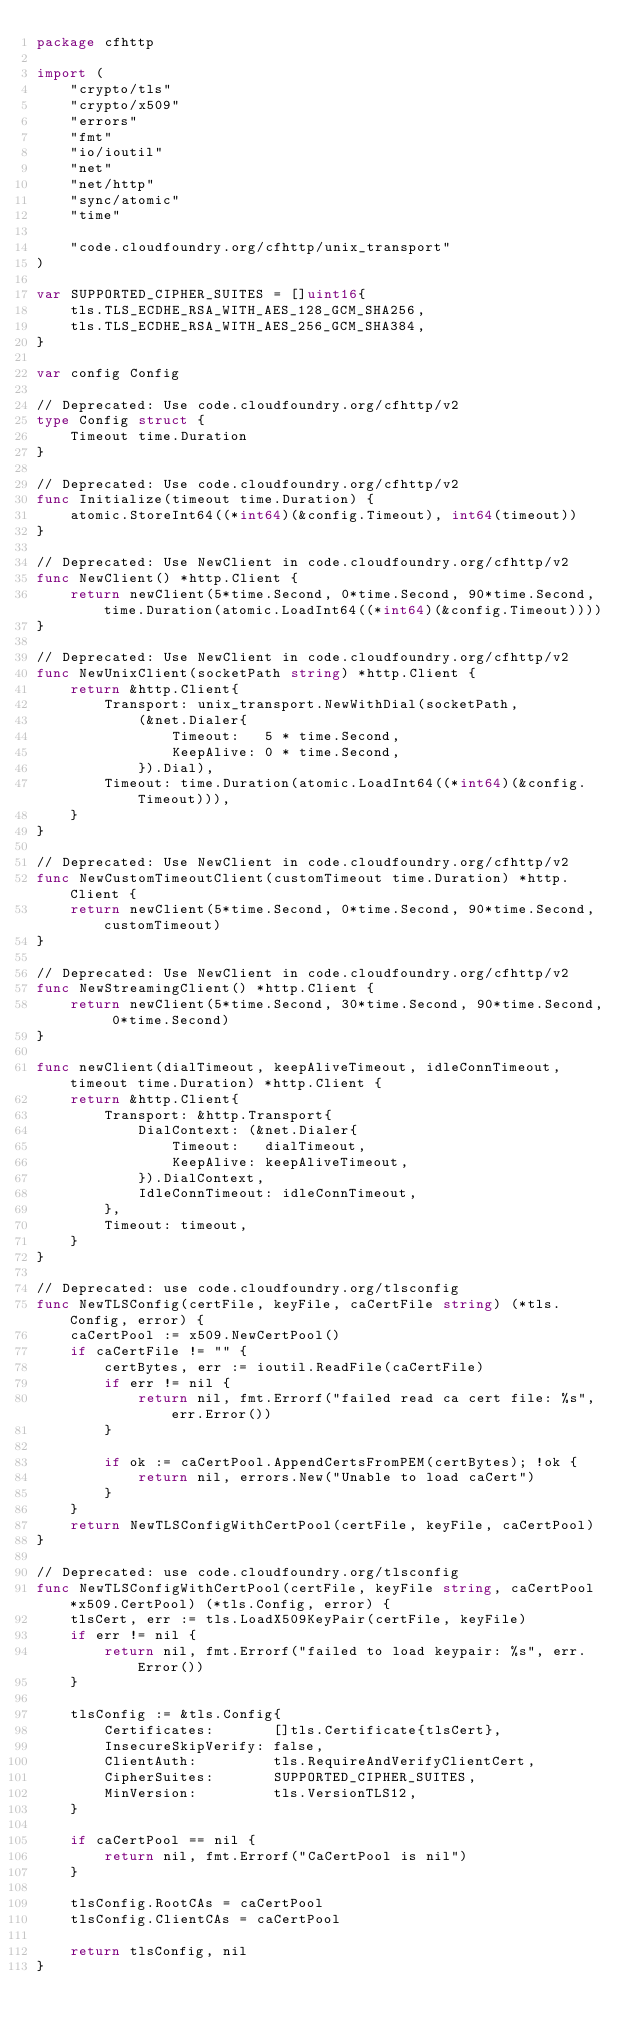Convert code to text. <code><loc_0><loc_0><loc_500><loc_500><_Go_>package cfhttp

import (
	"crypto/tls"
	"crypto/x509"
	"errors"
	"fmt"
	"io/ioutil"
	"net"
	"net/http"
	"sync/atomic"
	"time"

	"code.cloudfoundry.org/cfhttp/unix_transport"
)

var SUPPORTED_CIPHER_SUITES = []uint16{
	tls.TLS_ECDHE_RSA_WITH_AES_128_GCM_SHA256,
	tls.TLS_ECDHE_RSA_WITH_AES_256_GCM_SHA384,
}

var config Config

// Deprecated: Use code.cloudfoundry.org/cfhttp/v2
type Config struct {
	Timeout time.Duration
}

// Deprecated: Use code.cloudfoundry.org/cfhttp/v2
func Initialize(timeout time.Duration) {
	atomic.StoreInt64((*int64)(&config.Timeout), int64(timeout))
}

// Deprecated: Use NewClient in code.cloudfoundry.org/cfhttp/v2
func NewClient() *http.Client {
	return newClient(5*time.Second, 0*time.Second, 90*time.Second, time.Duration(atomic.LoadInt64((*int64)(&config.Timeout))))
}

// Deprecated: Use NewClient in code.cloudfoundry.org/cfhttp/v2
func NewUnixClient(socketPath string) *http.Client {
	return &http.Client{
		Transport: unix_transport.NewWithDial(socketPath,
			(&net.Dialer{
				Timeout:   5 * time.Second,
				KeepAlive: 0 * time.Second,
			}).Dial),
		Timeout: time.Duration(atomic.LoadInt64((*int64)(&config.Timeout))),
	}
}

// Deprecated: Use NewClient in code.cloudfoundry.org/cfhttp/v2
func NewCustomTimeoutClient(customTimeout time.Duration) *http.Client {
	return newClient(5*time.Second, 0*time.Second, 90*time.Second, customTimeout)
}

// Deprecated: Use NewClient in code.cloudfoundry.org/cfhttp/v2
func NewStreamingClient() *http.Client {
	return newClient(5*time.Second, 30*time.Second, 90*time.Second, 0*time.Second)
}

func newClient(dialTimeout, keepAliveTimeout, idleConnTimeout, timeout time.Duration) *http.Client {
	return &http.Client{
		Transport: &http.Transport{
			DialContext: (&net.Dialer{
				Timeout:   dialTimeout,
				KeepAlive: keepAliveTimeout,
			}).DialContext,
			IdleConnTimeout: idleConnTimeout,
		},
		Timeout: timeout,
	}
}

// Deprecated: use code.cloudfoundry.org/tlsconfig
func NewTLSConfig(certFile, keyFile, caCertFile string) (*tls.Config, error) {
	caCertPool := x509.NewCertPool()
	if caCertFile != "" {
		certBytes, err := ioutil.ReadFile(caCertFile)
		if err != nil {
			return nil, fmt.Errorf("failed read ca cert file: %s", err.Error())
		}

		if ok := caCertPool.AppendCertsFromPEM(certBytes); !ok {
			return nil, errors.New("Unable to load caCert")
		}
	}
	return NewTLSConfigWithCertPool(certFile, keyFile, caCertPool)
}

// Deprecated: use code.cloudfoundry.org/tlsconfig
func NewTLSConfigWithCertPool(certFile, keyFile string, caCertPool *x509.CertPool) (*tls.Config, error) {
	tlsCert, err := tls.LoadX509KeyPair(certFile, keyFile)
	if err != nil {
		return nil, fmt.Errorf("failed to load keypair: %s", err.Error())
	}

	tlsConfig := &tls.Config{
		Certificates:       []tls.Certificate{tlsCert},
		InsecureSkipVerify: false,
		ClientAuth:         tls.RequireAndVerifyClientCert,
		CipherSuites:       SUPPORTED_CIPHER_SUITES,
		MinVersion:         tls.VersionTLS12,
	}

	if caCertPool == nil {
		return nil, fmt.Errorf("CaCertPool is nil")
	}

	tlsConfig.RootCAs = caCertPool
	tlsConfig.ClientCAs = caCertPool

	return tlsConfig, nil
}
</code> 